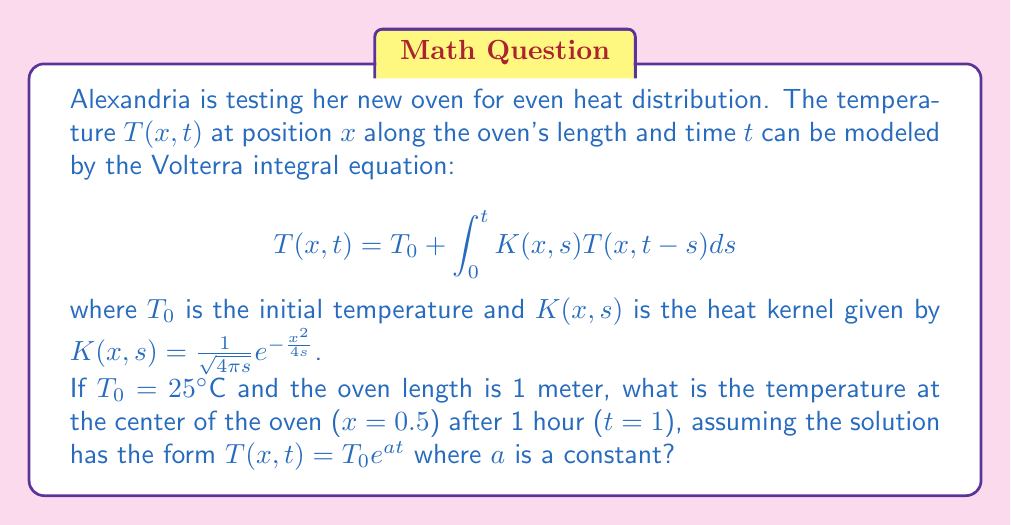Provide a solution to this math problem. Let's solve this step-by-step:

1) We're given that $T(x,t) = T_0 e^{at}$. Let's substitute this into the integral equation:

   $$T_0 e^{at} = T_0 + \int_0^t K(x,s) T_0 e^{a(t-s)} ds$$

2) Divide both sides by $T_0$:

   $$e^{at} = 1 + \int_0^t K(x,s) e^{a(t-s)} ds$$

3) Now, let's substitute the given heat kernel and $x=0.5$:

   $$e^{at} = 1 + \int_0^t \frac{1}{\sqrt{4\pi s}} e^{-\frac{0.5^2}{4s}} e^{a(t-s)} ds$$

4) To solve this, we need to find $a$. Let's differentiate both sides with respect to $t$:

   $$ae^{at} = \frac{1}{\sqrt{4\pi t}} e^{-\frac{0.5^2}{4t}} e^{a(t-t)} = \frac{1}{\sqrt{4\pi t}} e^{-\frac{0.5^2}{4t}}$$

5) Divide both sides by $e^{at}$:

   $$a = \frac{1}{\sqrt{4\pi t}} e^{-\frac{0.5^2}{4t} - at}$$

6) This equation should hold for all $t$. Let's consider $t \to \infty$. The right side approaches 0, so $a$ must be 0.

7) Therefore, $T(x,t) = T_0 e^{0t} = T_0 = 25°C$

8) This means the temperature remains constant at the initial temperature, which is physically reasonable for a well-insulated oven maintaining a steady temperature.
Answer: $25°C$ 